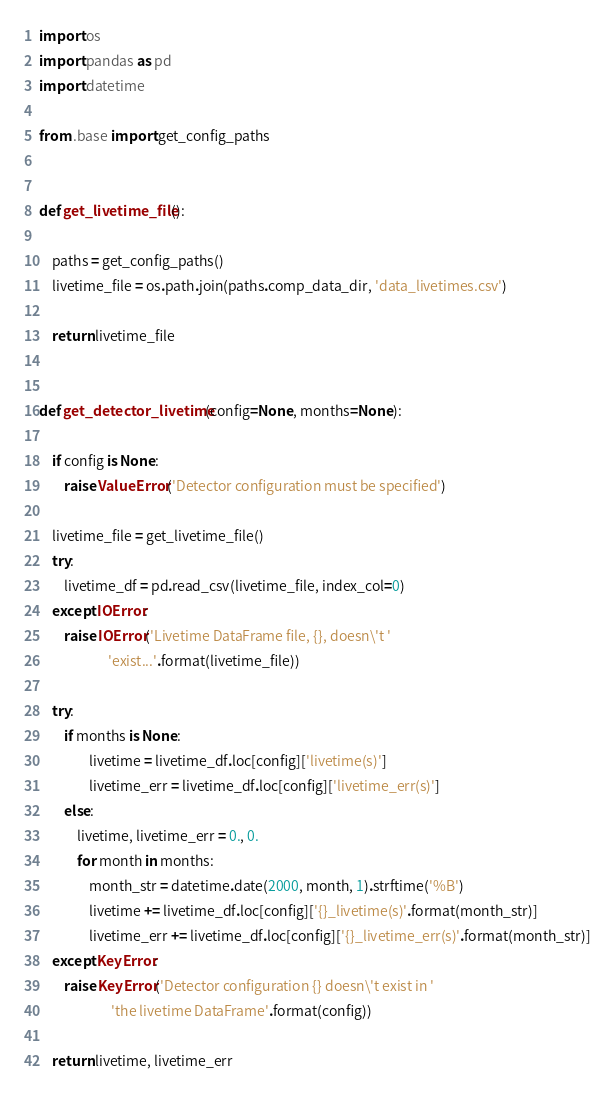<code> <loc_0><loc_0><loc_500><loc_500><_Python_>
import os
import pandas as pd
import datetime

from .base import get_config_paths


def get_livetime_file():

    paths = get_config_paths()
    livetime_file = os.path.join(paths.comp_data_dir, 'data_livetimes.csv')

    return livetime_file


def get_detector_livetime(config=None, months=None):

    if config is None:
        raise ValueError('Detector configuration must be specified')

    livetime_file = get_livetime_file()
    try:
        livetime_df = pd.read_csv(livetime_file, index_col=0)
    except IOError:
        raise IOError('Livetime DataFrame file, {}, doesn\'t '
                      'exist...'.format(livetime_file))

    try:
        if months is None:
                livetime = livetime_df.loc[config]['livetime(s)']
                livetime_err = livetime_df.loc[config]['livetime_err(s)']
        else:
            livetime, livetime_err = 0., 0.
            for month in months:
                month_str = datetime.date(2000, month, 1).strftime('%B')
                livetime += livetime_df.loc[config]['{}_livetime(s)'.format(month_str)]
                livetime_err += livetime_df.loc[config]['{}_livetime_err(s)'.format(month_str)]
    except KeyError:
        raise KeyError('Detector configuration {} doesn\'t exist in '
                       'the livetime DataFrame'.format(config))

    return livetime, livetime_err
</code> 